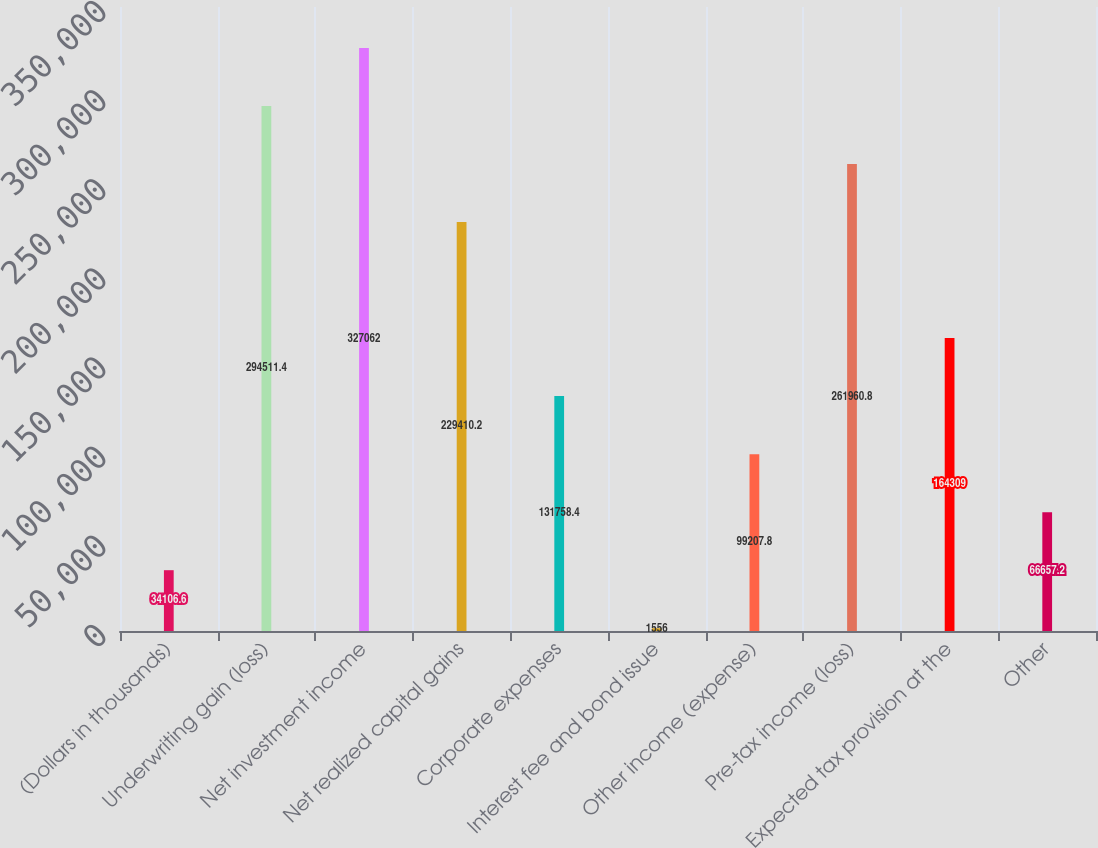<chart> <loc_0><loc_0><loc_500><loc_500><bar_chart><fcel>(Dollars in thousands)<fcel>Underwriting gain (loss)<fcel>Net investment income<fcel>Net realized capital gains<fcel>Corporate expenses<fcel>Interest fee and bond issue<fcel>Other income (expense)<fcel>Pre-tax income (loss)<fcel>Expected tax provision at the<fcel>Other<nl><fcel>34106.6<fcel>294511<fcel>327062<fcel>229410<fcel>131758<fcel>1556<fcel>99207.8<fcel>261961<fcel>164309<fcel>66657.2<nl></chart> 